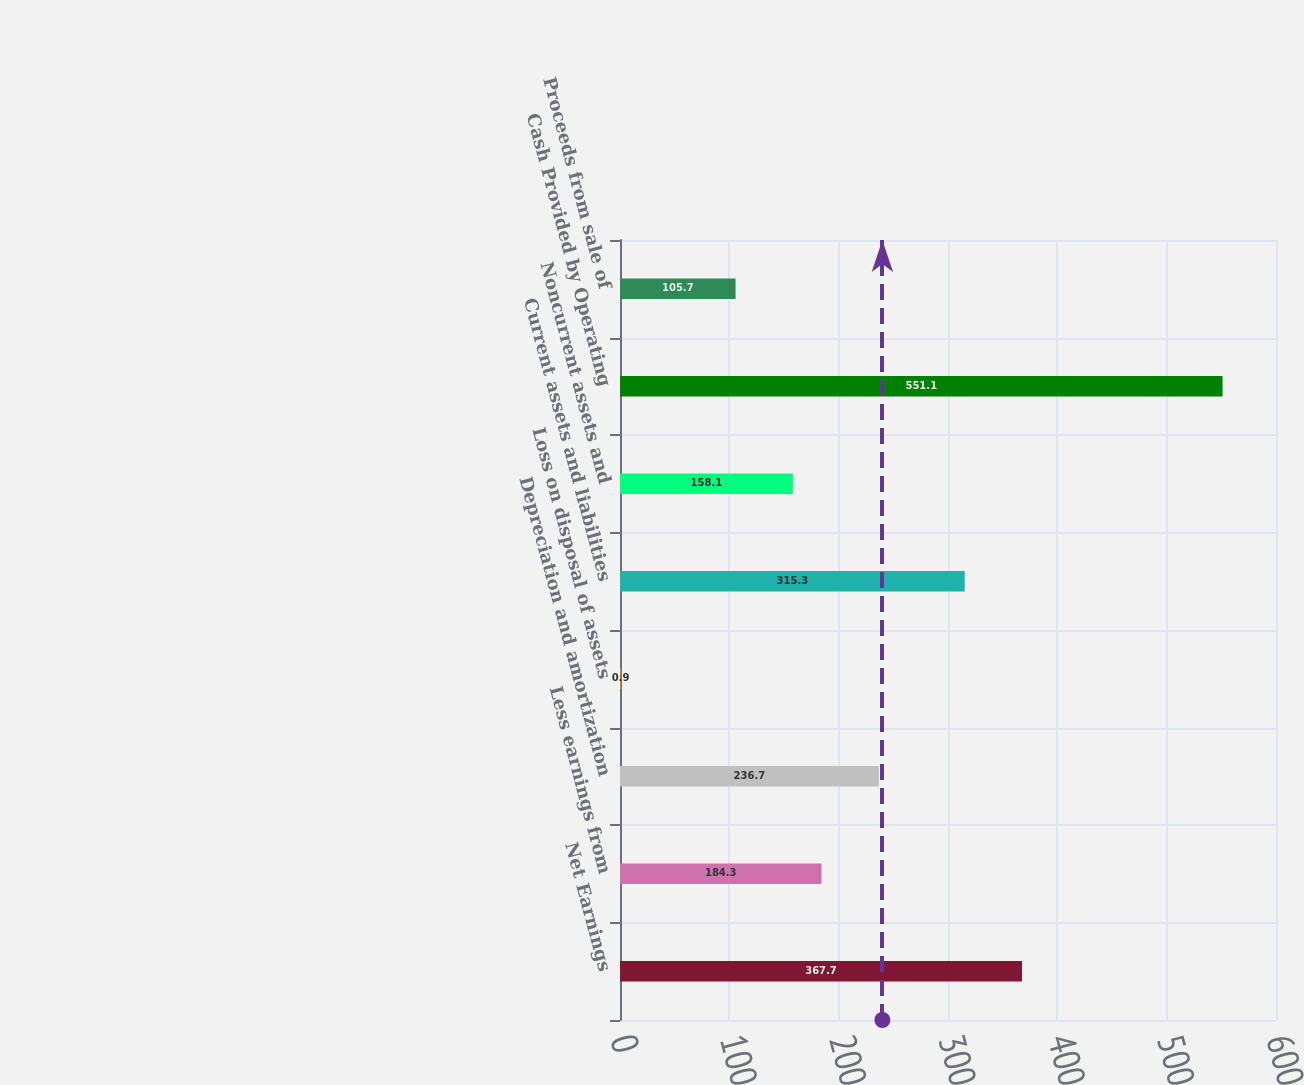Convert chart. <chart><loc_0><loc_0><loc_500><loc_500><bar_chart><fcel>Net Earnings<fcel>Less earnings from<fcel>Depreciation and amortization<fcel>Loss on disposal of assets<fcel>Current assets and liabilities<fcel>Noncurrent assets and<fcel>Cash Provided by Operating<fcel>Proceeds from sale of<nl><fcel>367.7<fcel>184.3<fcel>236.7<fcel>0.9<fcel>315.3<fcel>158.1<fcel>551.1<fcel>105.7<nl></chart> 